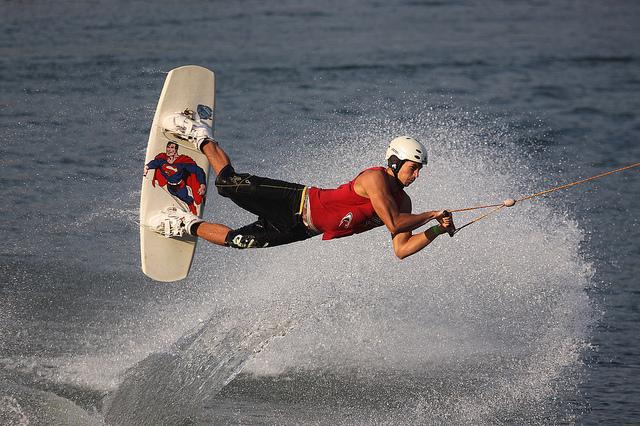What is the skier hanging on to?
Write a very short answer. Rope. Is the girl skiing?
Write a very short answer. No. What trick is this man performing?
Concise answer only. Water skiing. What color is the Beach sticker?
Keep it brief. Blue. What color are his shorts?
Short answer required. Black. Whose sticker is their on skating board?
Short answer required. Superman. What is the man holding in his right hand?
Write a very short answer. Rope. What colors make the checkerboard pattern on his shirt?
Quick response, please. Red. 